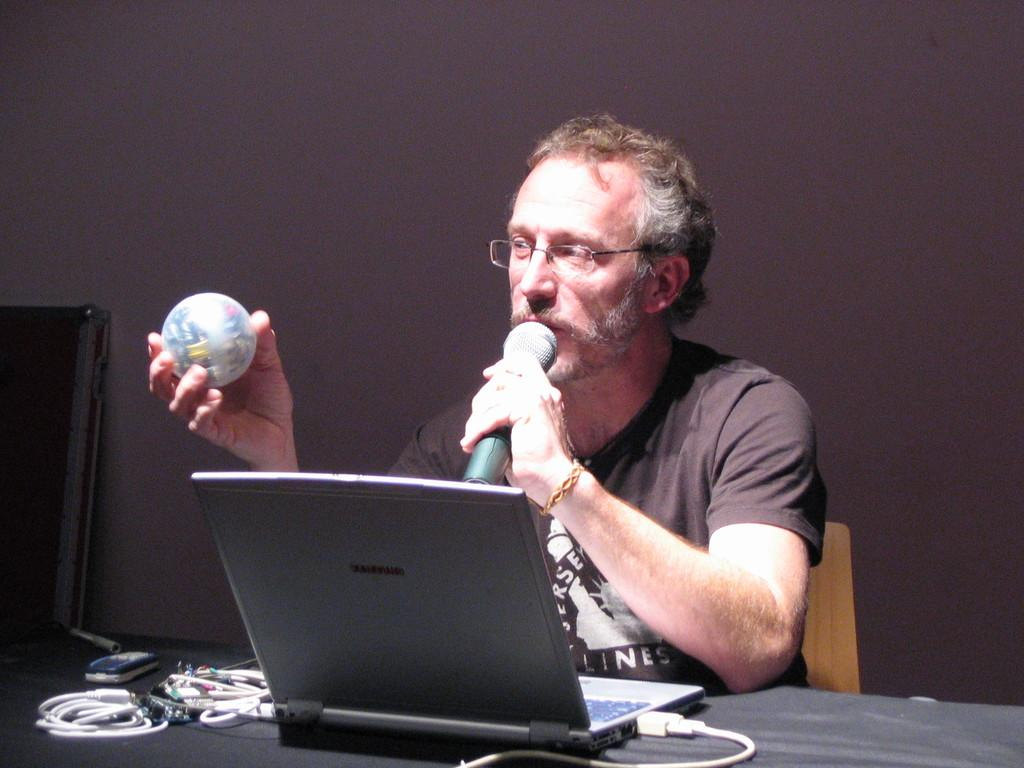What is the man in the image doing? The man is sitting on a chair and holding a mic. What else is the man holding in the image? The man is also holding a ball. What is on the table in front of the man? There is a laptop, a cable, and a mobile on the table. What might the man be using the mic for? The man might be using the mic for a presentation or speech. What type of bread is the man eating in the image? There is no bread present in the image. What time of day is it in the image, given the presence of a morning bell? There is no mention of a bell, let alone a morning bell, in the image. 